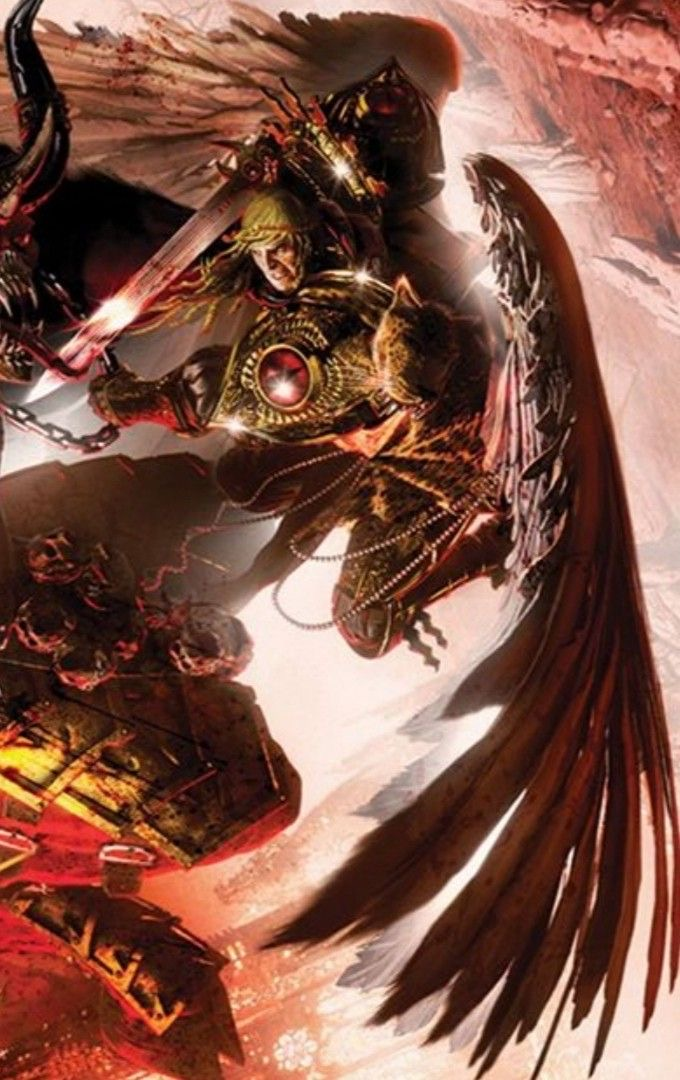analyze this image in detail  The image is of a Blood Angel Space Marine from the Warhammer 40,000 universe. He is depicted as a tall, muscular man with pale skin and black hair. He is wearing a suit of red and gold power armor, and he is armed with a pair of swords. The Blood Angels are a chapter of Space Marines who are known for their close combat prowess and their use of jump packs. The image is set on a battlefield, and the Blood Angel Space Marine is surrounded by the bodies of his enemies. The ground is covered in blood, and the air is thick with the smell of death. The Blood Angel Space Marine is a symbol of hope for the Imperium of Man, and he is a reminder that even in the darkest of times, there is always hope for victory. 